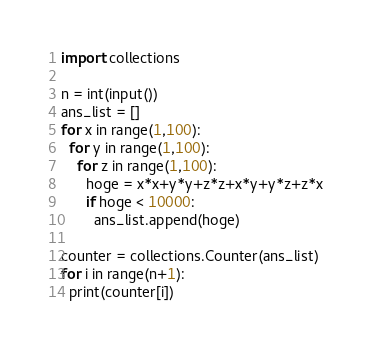Convert code to text. <code><loc_0><loc_0><loc_500><loc_500><_Python_>import collections

n = int(input())
ans_list = []
for x in range(1,100):
  for y in range(1,100):
    for z in range(1,100):
      hoge = x*x+y*y+z*z+x*y+y*z+z*x
      if hoge < 10000:
        ans_list.append(hoge)

counter = collections.Counter(ans_list)
for i in range(n+1):
  print(counter[i])</code> 